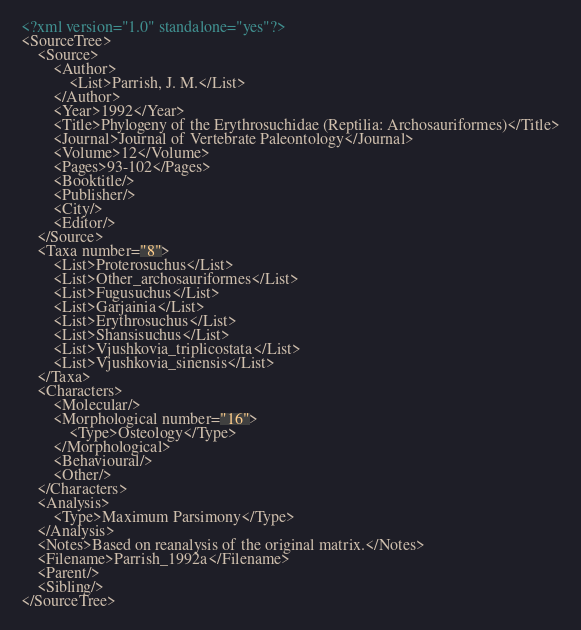<code> <loc_0><loc_0><loc_500><loc_500><_XML_><?xml version="1.0" standalone="yes"?>
<SourceTree>
	<Source>
		<Author>
			<List>Parrish, J. M.</List>
		</Author>
		<Year>1992</Year>
		<Title>Phylogeny of the Erythrosuchidae (Reptilia: Archosauriformes)</Title>
		<Journal>Journal of Vertebrate Paleontology</Journal>
		<Volume>12</Volume>
		<Pages>93-102</Pages>
		<Booktitle/>
		<Publisher/>
		<City/>
		<Editor/>
	</Source>
	<Taxa number="8">
		<List>Proterosuchus</List>
		<List>Other_archosauriformes</List>
		<List>Fugusuchus</List>
		<List>Garjainia</List>
		<List>Erythrosuchus</List>
		<List>Shansisuchus</List>
		<List>Vjushkovia_triplicostata</List>
		<List>Vjushkovia_sinensis</List>
	</Taxa>
	<Characters>
		<Molecular/>
		<Morphological number="16">
			<Type>Osteology</Type>
		</Morphological>
		<Behavioural/>
		<Other/>
	</Characters>
	<Analysis>
		<Type>Maximum Parsimony</Type>
	</Analysis>
	<Notes>Based on reanalysis of the original matrix.</Notes>
	<Filename>Parrish_1992a</Filename>
	<Parent/>
	<Sibling/>
</SourceTree>
</code> 